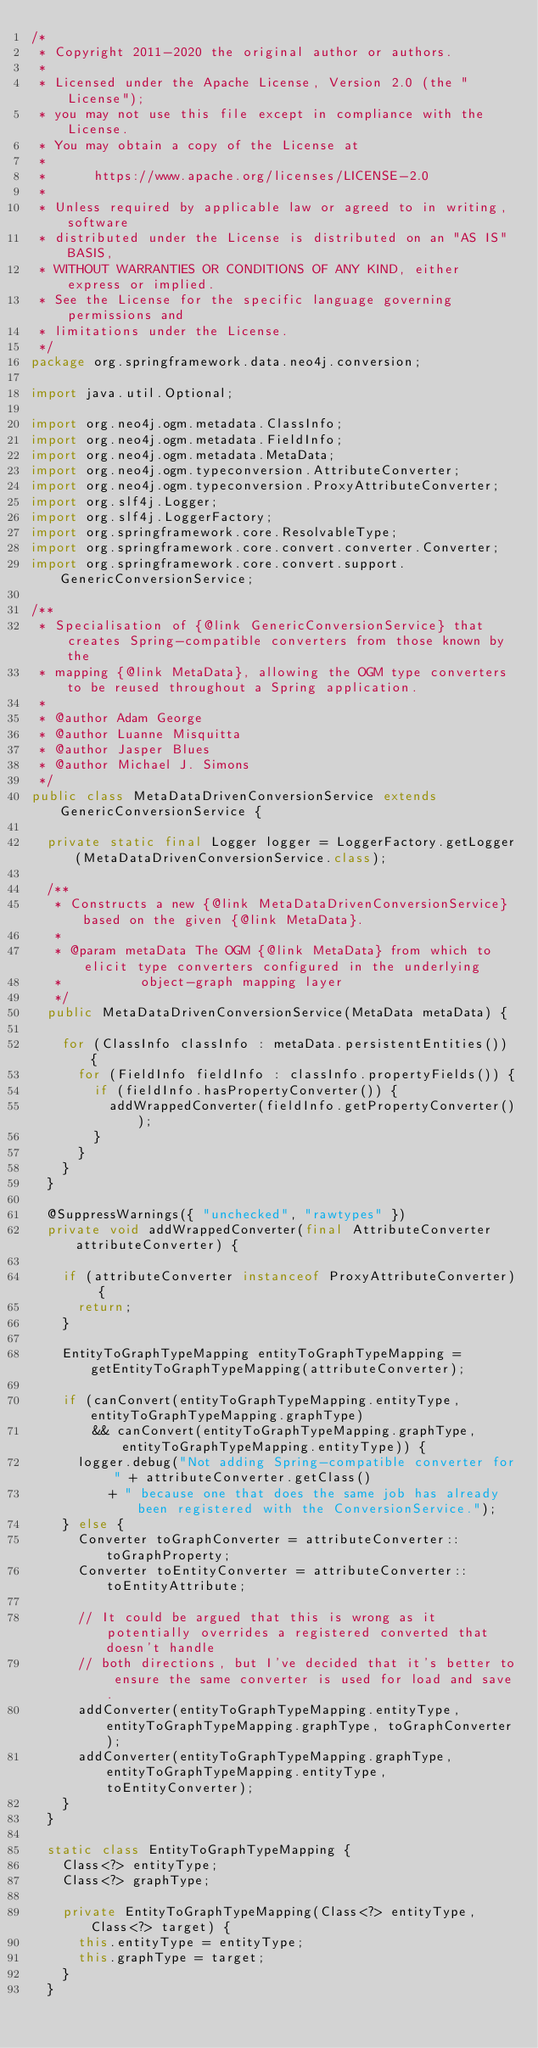Convert code to text. <code><loc_0><loc_0><loc_500><loc_500><_Java_>/*
 * Copyright 2011-2020 the original author or authors.
 *
 * Licensed under the Apache License, Version 2.0 (the "License");
 * you may not use this file except in compliance with the License.
 * You may obtain a copy of the License at
 *
 *      https://www.apache.org/licenses/LICENSE-2.0
 *
 * Unless required by applicable law or agreed to in writing, software
 * distributed under the License is distributed on an "AS IS" BASIS,
 * WITHOUT WARRANTIES OR CONDITIONS OF ANY KIND, either express or implied.
 * See the License for the specific language governing permissions and
 * limitations under the License.
 */
package org.springframework.data.neo4j.conversion;

import java.util.Optional;

import org.neo4j.ogm.metadata.ClassInfo;
import org.neo4j.ogm.metadata.FieldInfo;
import org.neo4j.ogm.metadata.MetaData;
import org.neo4j.ogm.typeconversion.AttributeConverter;
import org.neo4j.ogm.typeconversion.ProxyAttributeConverter;
import org.slf4j.Logger;
import org.slf4j.LoggerFactory;
import org.springframework.core.ResolvableType;
import org.springframework.core.convert.converter.Converter;
import org.springframework.core.convert.support.GenericConversionService;

/**
 * Specialisation of {@link GenericConversionService} that creates Spring-compatible converters from those known by the
 * mapping {@link MetaData}, allowing the OGM type converters to be reused throughout a Spring application.
 *
 * @author Adam George
 * @author Luanne Misquitta
 * @author Jasper Blues
 * @author Michael J. Simons
 */
public class MetaDataDrivenConversionService extends GenericConversionService {

	private static final Logger logger = LoggerFactory.getLogger(MetaDataDrivenConversionService.class);

	/**
	 * Constructs a new {@link MetaDataDrivenConversionService} based on the given {@link MetaData}.
	 *
	 * @param metaData The OGM {@link MetaData} from which to elicit type converters configured in the underlying
	 *          object-graph mapping layer
	 */
	public MetaDataDrivenConversionService(MetaData metaData) {

		for (ClassInfo classInfo : metaData.persistentEntities()) {
			for (FieldInfo fieldInfo : classInfo.propertyFields()) {
				if (fieldInfo.hasPropertyConverter()) {
					addWrappedConverter(fieldInfo.getPropertyConverter());
				}
			}
		}
	}

	@SuppressWarnings({ "unchecked", "rawtypes" })
	private void addWrappedConverter(final AttributeConverter attributeConverter) {

		if (attributeConverter instanceof ProxyAttributeConverter) {
			return;
		}

		EntityToGraphTypeMapping entityToGraphTypeMapping = getEntityToGraphTypeMapping(attributeConverter);

		if (canConvert(entityToGraphTypeMapping.entityType, entityToGraphTypeMapping.graphType)
				&& canConvert(entityToGraphTypeMapping.graphType, entityToGraphTypeMapping.entityType)) {
			logger.debug("Not adding Spring-compatible converter for " + attributeConverter.getClass()
					+ " because one that does the same job has already been registered with the ConversionService.");
		} else {
			Converter toGraphConverter = attributeConverter::toGraphProperty;
			Converter toEntityConverter = attributeConverter::toEntityAttribute;

			// It could be argued that this is wrong as it potentially overrides a registered converted that doesn't handle
			// both directions, but I've decided that it's better to ensure the same converter is used for load and save.
			addConverter(entityToGraphTypeMapping.entityType, entityToGraphTypeMapping.graphType, toGraphConverter);
			addConverter(entityToGraphTypeMapping.graphType, entityToGraphTypeMapping.entityType, toEntityConverter);
		}
	}

	static class EntityToGraphTypeMapping {
		Class<?> entityType;
		Class<?> graphType;

		private EntityToGraphTypeMapping(Class<?> entityType, Class<?> target) {
			this.entityType = entityType;
			this.graphType = target;
		}
	}
</code> 